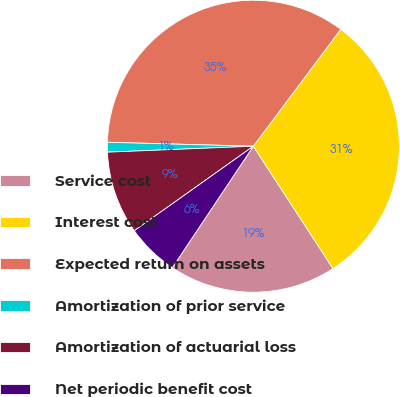Convert chart. <chart><loc_0><loc_0><loc_500><loc_500><pie_chart><fcel>Service cost<fcel>Interest cost<fcel>Expected return on assets<fcel>Amortization of prior service<fcel>Amortization of actuarial loss<fcel>Net periodic benefit cost<nl><fcel>18.55%<fcel>30.6%<fcel>34.79%<fcel>1.08%<fcel>9.18%<fcel>5.81%<nl></chart> 